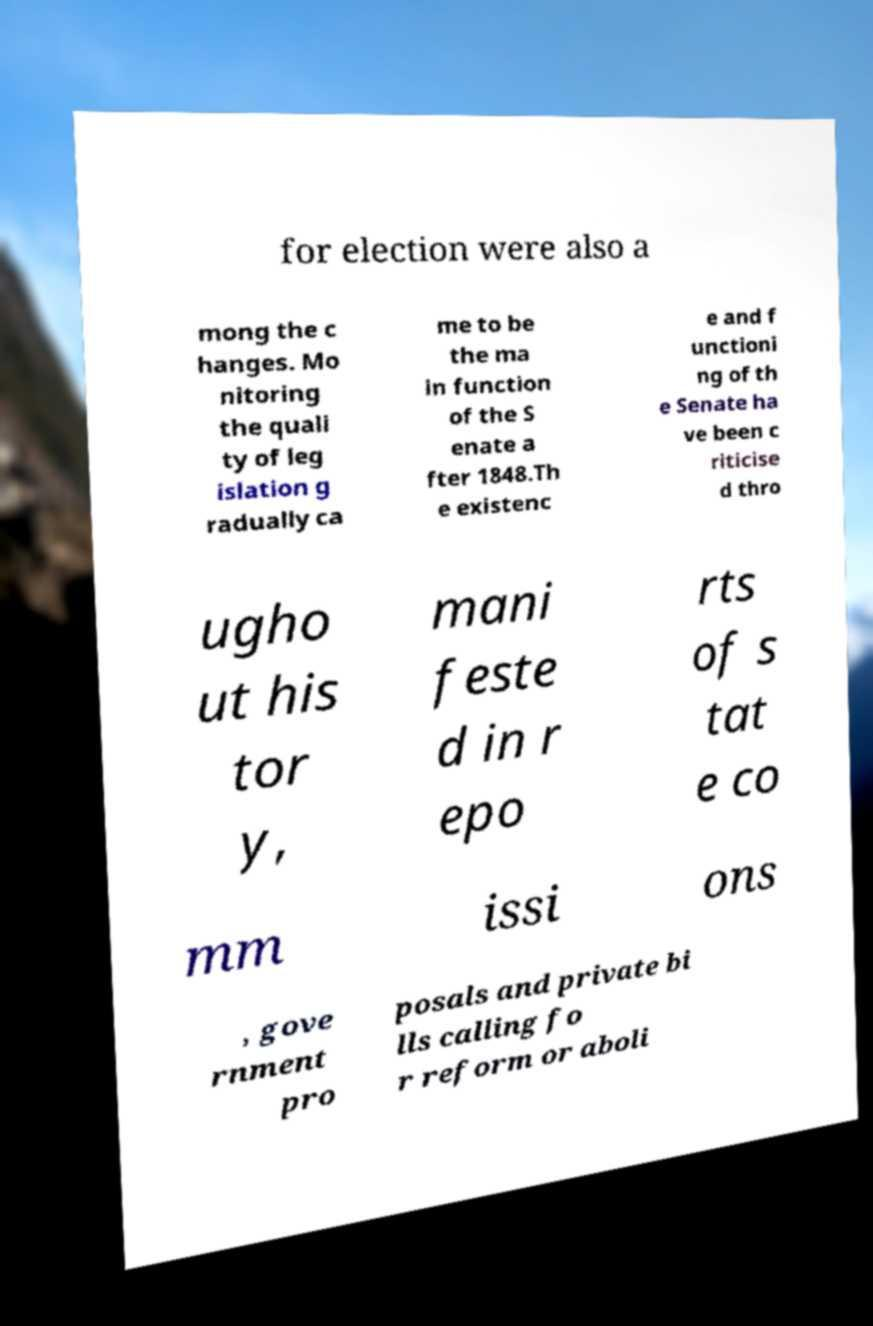What messages or text are displayed in this image? I need them in a readable, typed format. for election were also a mong the c hanges. Mo nitoring the quali ty of leg islation g radually ca me to be the ma in function of the S enate a fter 1848.Th e existenc e and f unctioni ng of th e Senate ha ve been c riticise d thro ugho ut his tor y, mani feste d in r epo rts of s tat e co mm issi ons , gove rnment pro posals and private bi lls calling fo r reform or aboli 